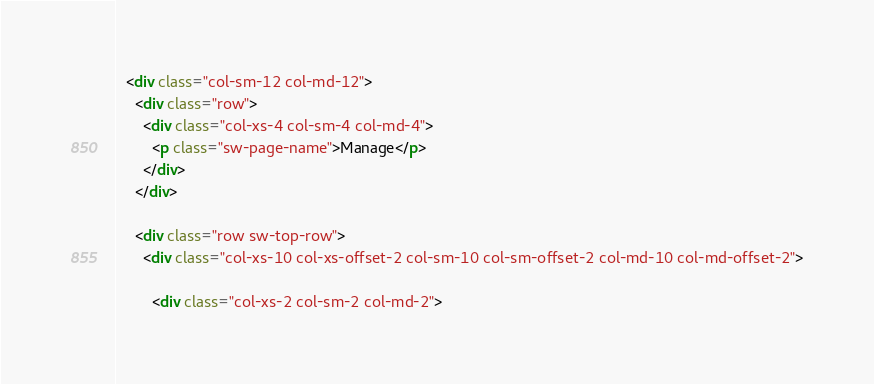<code> <loc_0><loc_0><loc_500><loc_500><_HTML_>  <div class="col-sm-12 col-md-12">
    <div class="row">
      <div class="col-xs-4 col-sm-4 col-md-4">
        <p class="sw-page-name">Manage</p>
      </div>
    </div>
  
    <div class="row sw-top-row">
      <div class="col-xs-10 col-xs-offset-2 col-sm-10 col-sm-offset-2 col-md-10 col-md-offset-2">
        
        <div class="col-xs-2 col-sm-2 col-md-2"></code> 